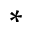Convert formula to latex. <formula><loc_0><loc_0><loc_500><loc_500>^ { * }</formula> 